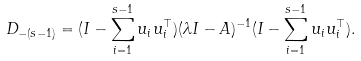Convert formula to latex. <formula><loc_0><loc_0><loc_500><loc_500>D _ { - ( s - 1 ) } = ( I - \sum _ { i = 1 } ^ { s - 1 } u _ { i } u _ { i } ^ { \top } ) ( \lambda I - A ) ^ { - 1 } ( I - \sum _ { i = 1 } ^ { s - 1 } u _ { i } u _ { i } ^ { \top } ) .</formula> 